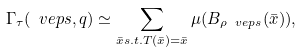<formula> <loc_0><loc_0><loc_500><loc_500>\Gamma _ { \tau } ( \ v e p s , q ) \simeq \sum _ { \bar { x } s . t . T ( \bar { x } ) = \bar { x } } \mu ( B _ { \rho \ v e p s } ( \bar { x } ) ) ,</formula> 